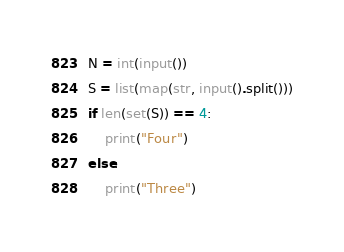Convert code to text. <code><loc_0><loc_0><loc_500><loc_500><_Python_>N = int(input())
S = list(map(str, input().split()))
if len(set(S)) == 4:
    print("Four")
else:
    print("Three")
</code> 